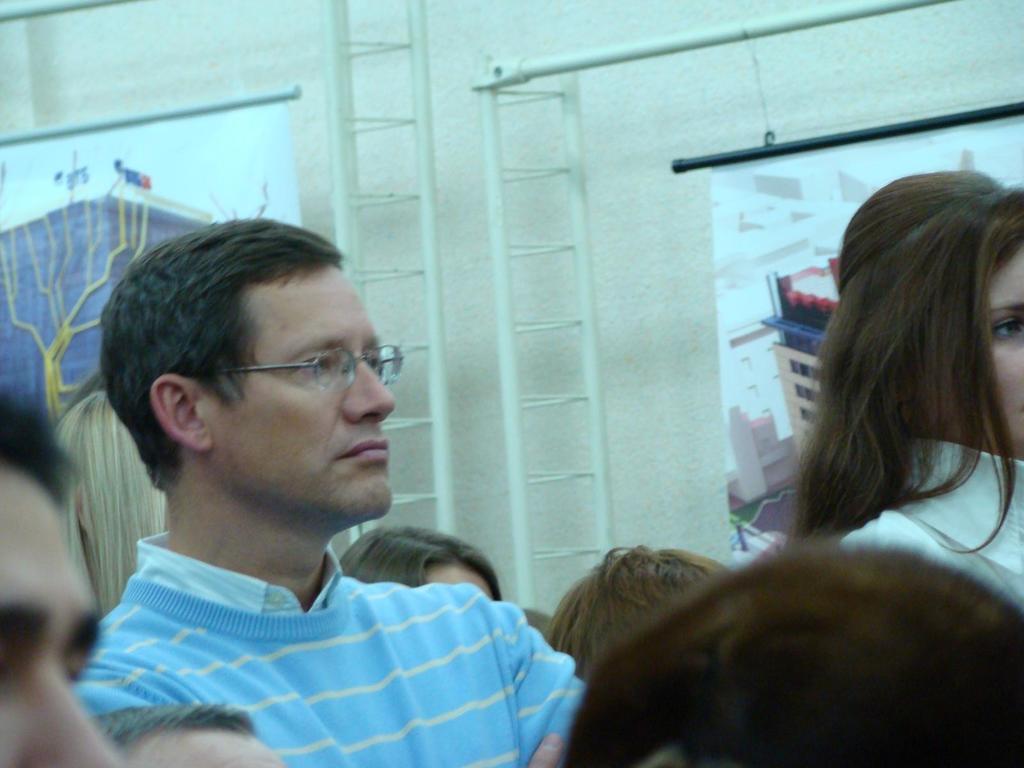Can you describe this image briefly? In the foreground of the picture we can see many people. In the middle of the picture we can see iron framed, posters and other objects. In the background there is a wall. 